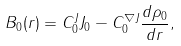Convert formula to latex. <formula><loc_0><loc_0><loc_500><loc_500>B _ { 0 } ( r ) = C ^ { J } _ { 0 } J _ { 0 } - C ^ { \nabla J } _ { 0 } \frac { d \rho _ { 0 } } { d r } ,</formula> 